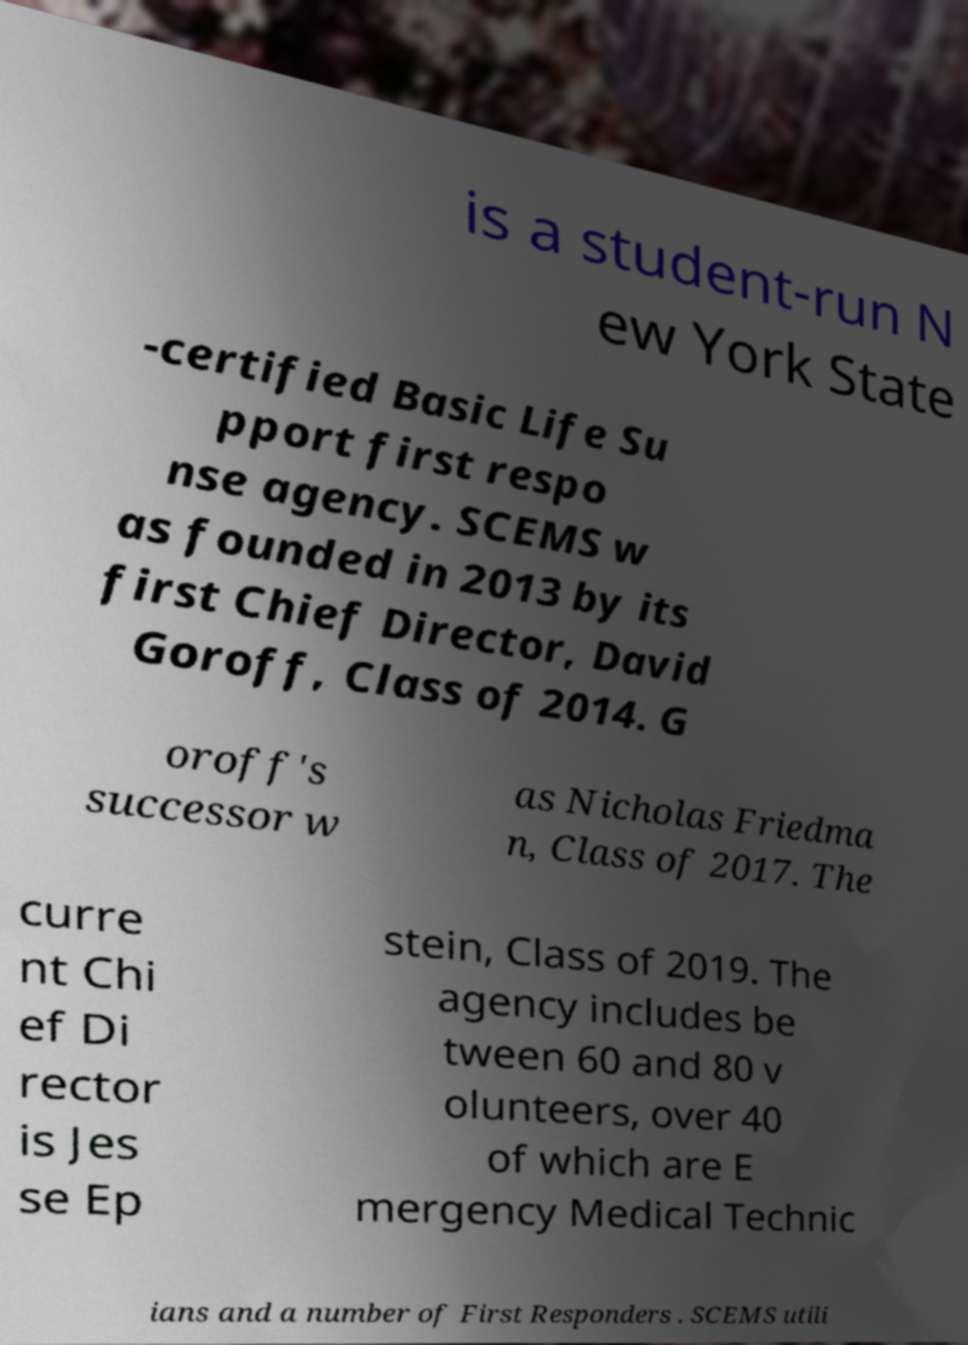Can you read and provide the text displayed in the image?This photo seems to have some interesting text. Can you extract and type it out for me? is a student-run N ew York State -certified Basic Life Su pport first respo nse agency. SCEMS w as founded in 2013 by its first Chief Director, David Goroff, Class of 2014. G oroff's successor w as Nicholas Friedma n, Class of 2017. The curre nt Chi ef Di rector is Jes se Ep stein, Class of 2019. The agency includes be tween 60 and 80 v olunteers, over 40 of which are E mergency Medical Technic ians and a number of First Responders . SCEMS utili 